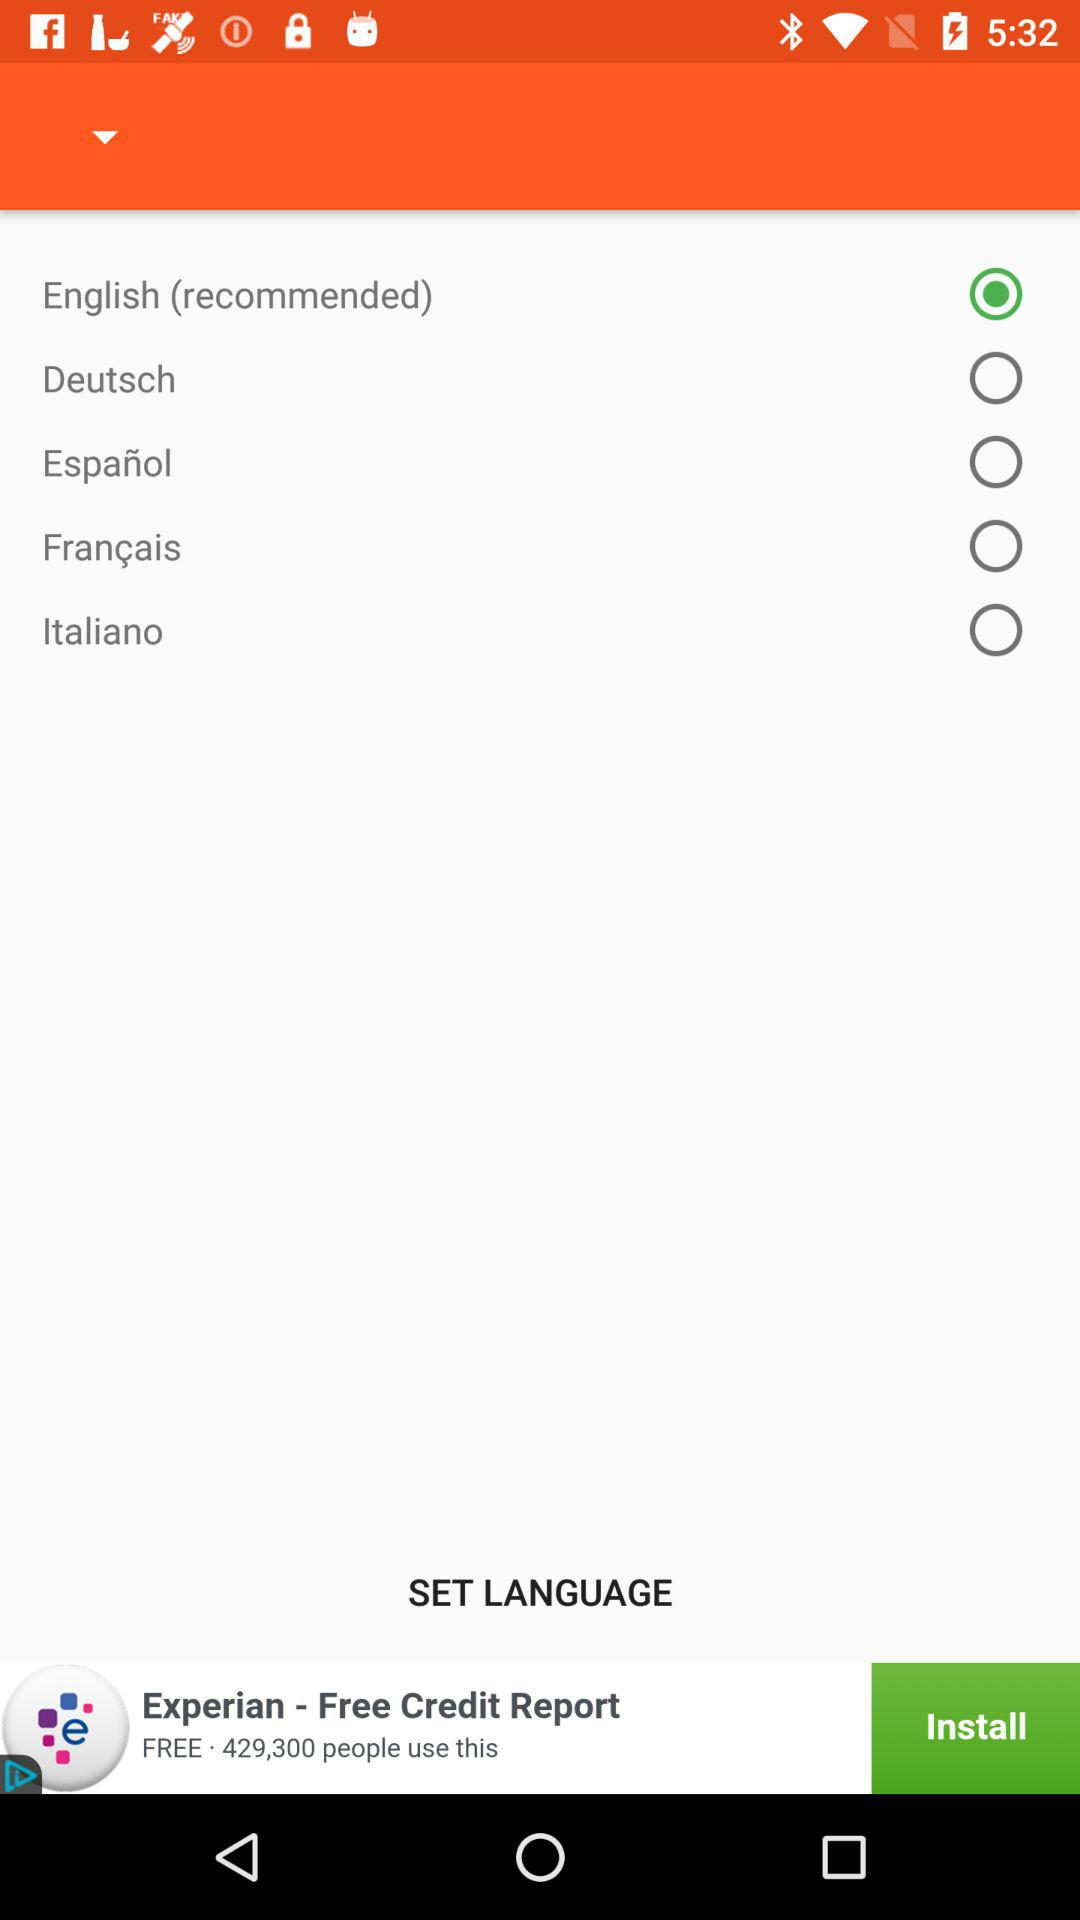What is the selected language? The selected language is English (recommended). 